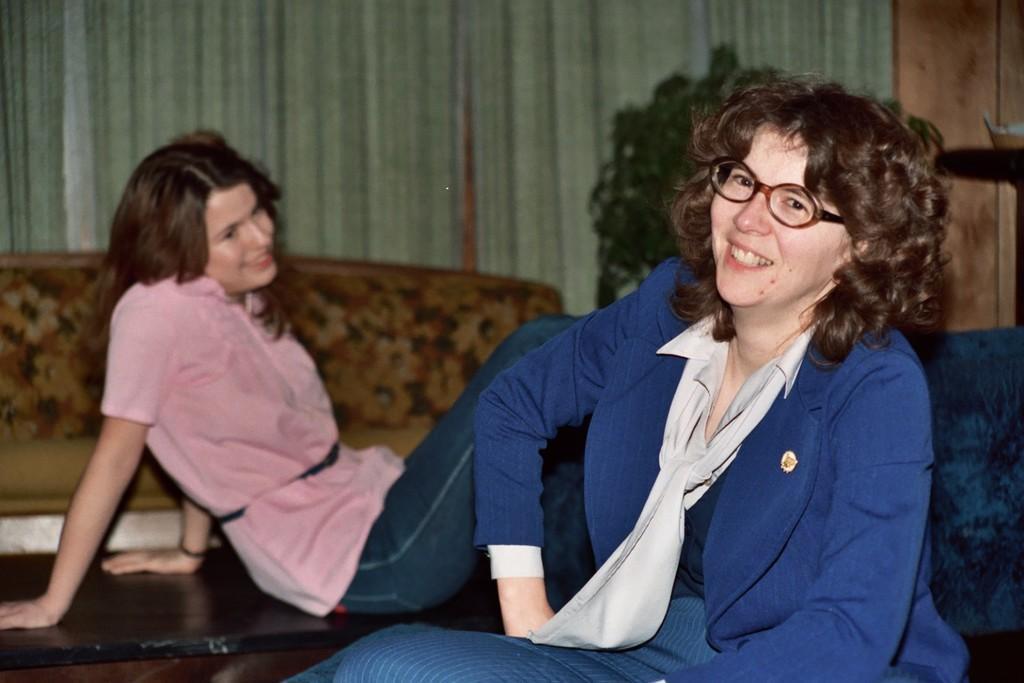Describe this image in one or two sentences. In this image we can see a woman wearing spectacles and smiling and posing for a photo and behind there is an another woman sitting on the surface which looks like a table. We can see a couch and the curtains in the background and there are some other objects in the room. 